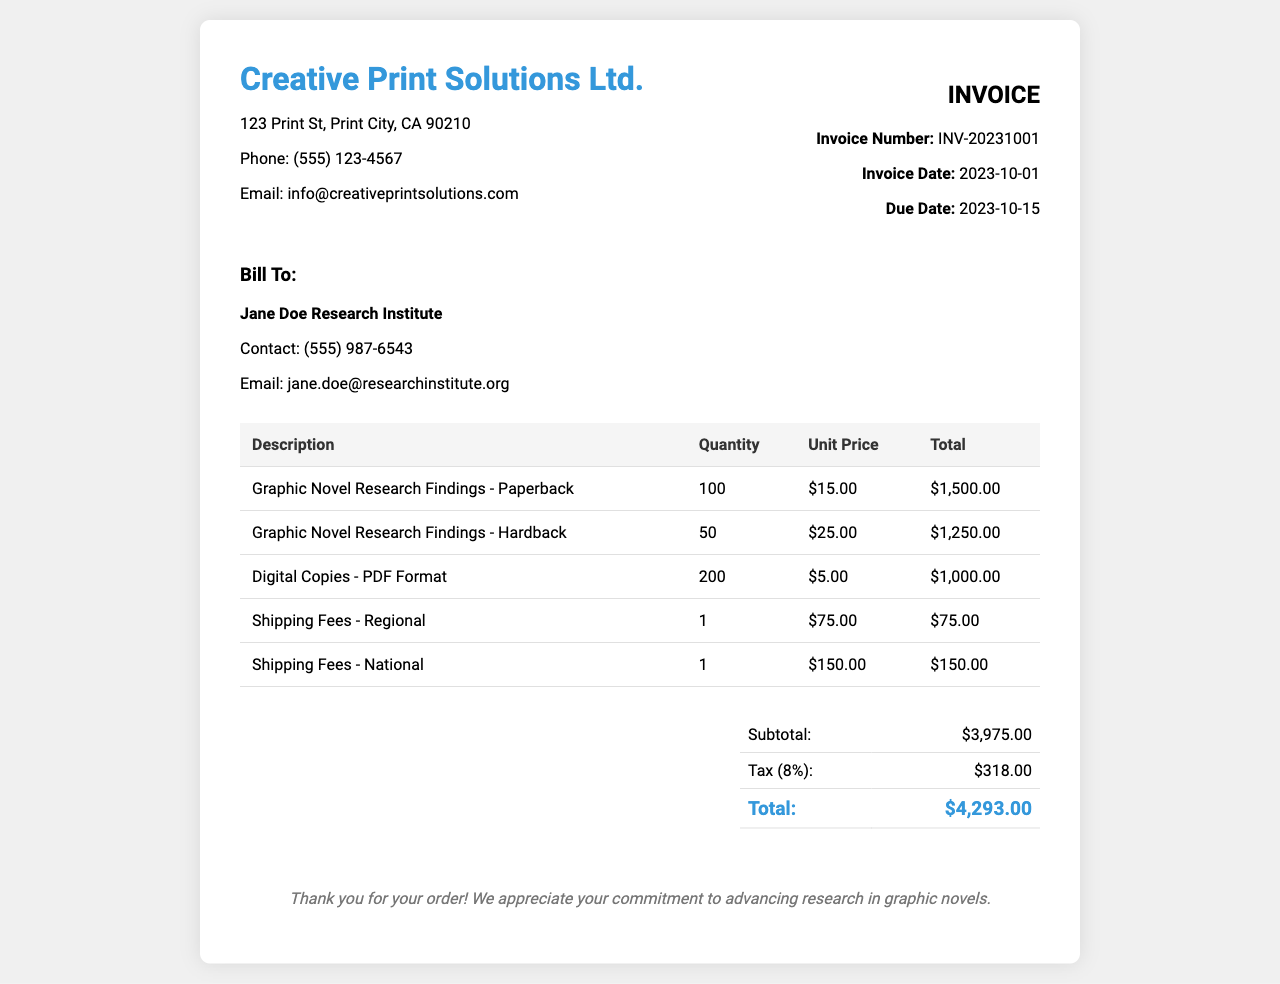what is the total amount due on the invoice? The total amount due is listed in the summary section of the invoice, which includes the subtotal and tax.
Answer: $4,293.00 who is the billing contact for this invoice? The billing contact name is provided in the billing information section as "Jane Doe Research Institute".
Answer: Jane Doe Research Institute what is the unit price of the paperback graphic novel? The unit price is specified in the invoice table for the paperback graphic novel.
Answer: $15.00 how many hardback copies were ordered? The quantity of hardback copies ordered can be found in the table under the hardback graphic novel entry.
Answer: 50 what is the date of the invoice? The invoice date is provided in the invoice information area.
Answer: 2023-10-01 what is the subtotal before tax? The subtotal is calculated before any tax is added and is shown in the summary table.
Answer: $3,975.00 how much is the tax rate applied to this invoice? The tax rate is referenced in the summary section of the invoice.
Answer: 8% what is the shipping fee for regional delivery? The shipping fee for regional delivery is explicitly listed in the table under shipping fees.
Answer: $75.00 how many digital copies were ordered? The number of digital copies ordered is specified in the invoice table related to PDF format.
Answer: 200 